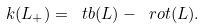Convert formula to latex. <formula><loc_0><loc_0><loc_500><loc_500>\sl k ( L _ { + } ) = \ t b ( L ) - \ r o t ( L ) .</formula> 